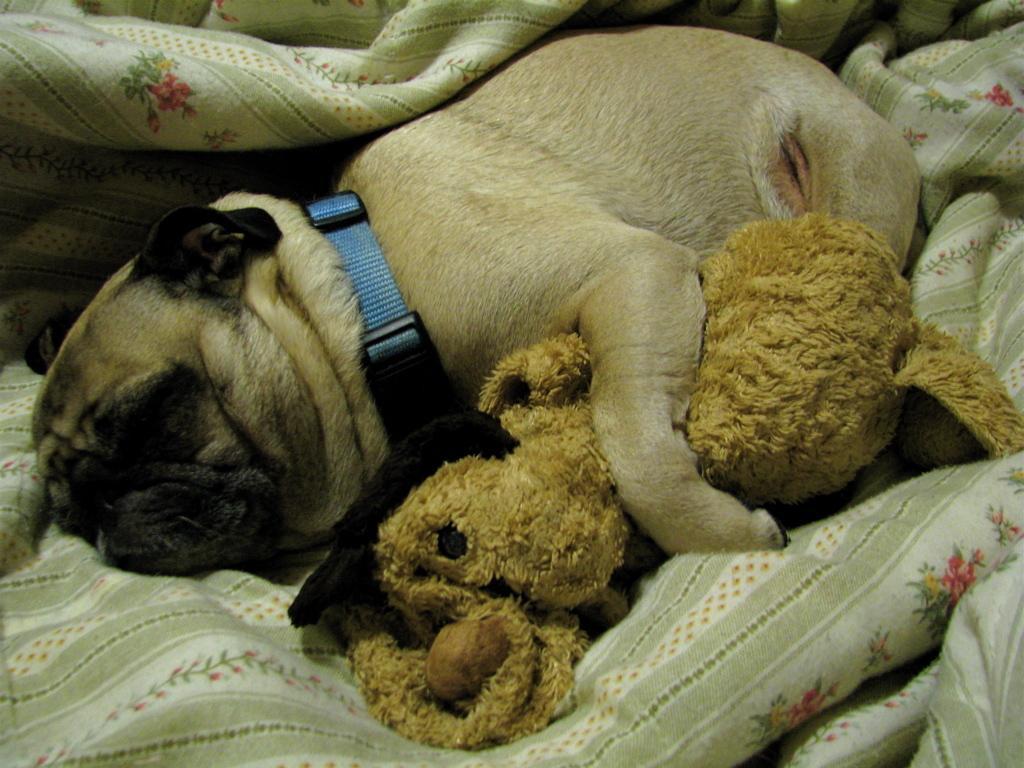Please provide a concise description of this image. In this image we can see a dog sleeping on a blanket. There is a toy in the image. 